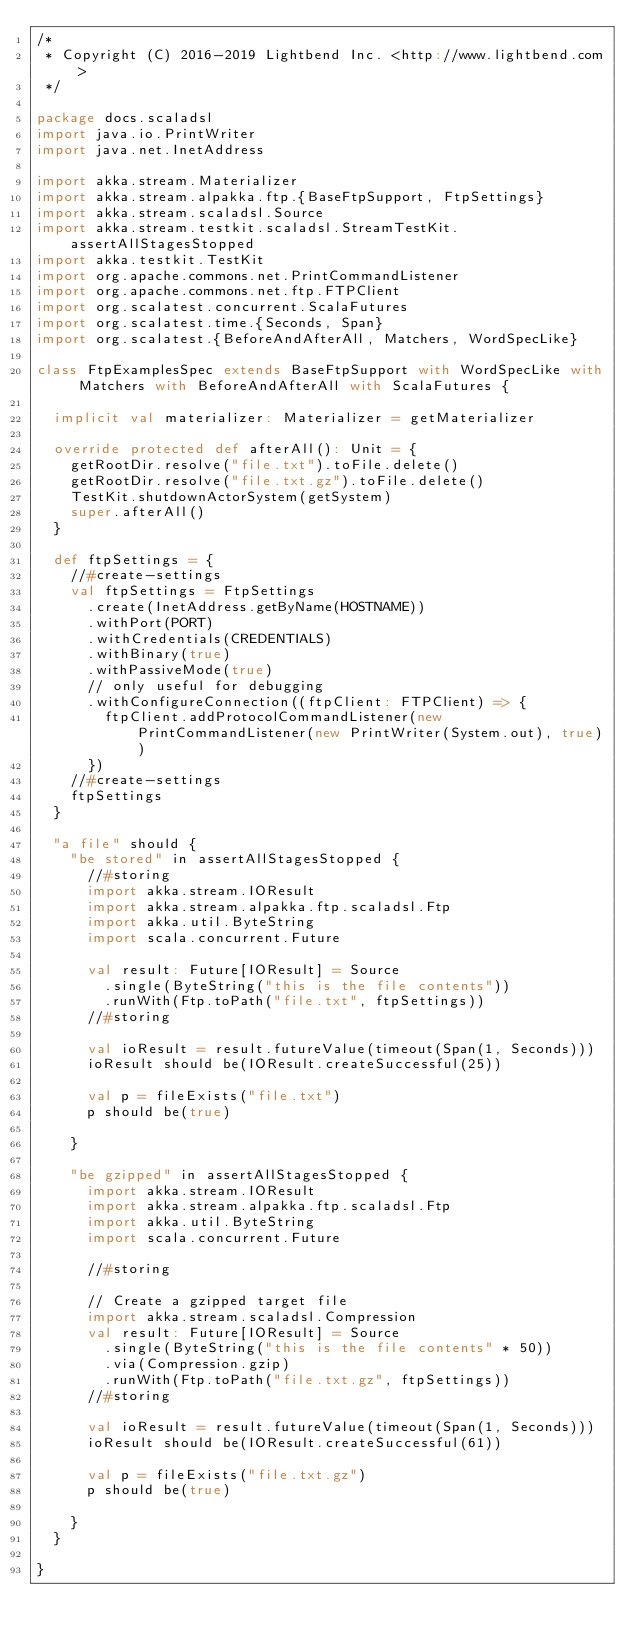Convert code to text. <code><loc_0><loc_0><loc_500><loc_500><_Scala_>/*
 * Copyright (C) 2016-2019 Lightbend Inc. <http://www.lightbend.com>
 */

package docs.scaladsl
import java.io.PrintWriter
import java.net.InetAddress

import akka.stream.Materializer
import akka.stream.alpakka.ftp.{BaseFtpSupport, FtpSettings}
import akka.stream.scaladsl.Source
import akka.stream.testkit.scaladsl.StreamTestKit.assertAllStagesStopped
import akka.testkit.TestKit
import org.apache.commons.net.PrintCommandListener
import org.apache.commons.net.ftp.FTPClient
import org.scalatest.concurrent.ScalaFutures
import org.scalatest.time.{Seconds, Span}
import org.scalatest.{BeforeAndAfterAll, Matchers, WordSpecLike}

class FtpExamplesSpec extends BaseFtpSupport with WordSpecLike with Matchers with BeforeAndAfterAll with ScalaFutures {

  implicit val materializer: Materializer = getMaterializer

  override protected def afterAll(): Unit = {
    getRootDir.resolve("file.txt").toFile.delete()
    getRootDir.resolve("file.txt.gz").toFile.delete()
    TestKit.shutdownActorSystem(getSystem)
    super.afterAll()
  }

  def ftpSettings = {
    //#create-settings
    val ftpSettings = FtpSettings
      .create(InetAddress.getByName(HOSTNAME))
      .withPort(PORT)
      .withCredentials(CREDENTIALS)
      .withBinary(true)
      .withPassiveMode(true)
      // only useful for debugging
      .withConfigureConnection((ftpClient: FTPClient) => {
        ftpClient.addProtocolCommandListener(new PrintCommandListener(new PrintWriter(System.out), true))
      })
    //#create-settings
    ftpSettings
  }

  "a file" should {
    "be stored" in assertAllStagesStopped {
      //#storing
      import akka.stream.IOResult
      import akka.stream.alpakka.ftp.scaladsl.Ftp
      import akka.util.ByteString
      import scala.concurrent.Future

      val result: Future[IOResult] = Source
        .single(ByteString("this is the file contents"))
        .runWith(Ftp.toPath("file.txt", ftpSettings))
      //#storing

      val ioResult = result.futureValue(timeout(Span(1, Seconds)))
      ioResult should be(IOResult.createSuccessful(25))

      val p = fileExists("file.txt")
      p should be(true)

    }

    "be gzipped" in assertAllStagesStopped {
      import akka.stream.IOResult
      import akka.stream.alpakka.ftp.scaladsl.Ftp
      import akka.util.ByteString
      import scala.concurrent.Future

      //#storing

      // Create a gzipped target file
      import akka.stream.scaladsl.Compression
      val result: Future[IOResult] = Source
        .single(ByteString("this is the file contents" * 50))
        .via(Compression.gzip)
        .runWith(Ftp.toPath("file.txt.gz", ftpSettings))
      //#storing

      val ioResult = result.futureValue(timeout(Span(1, Seconds)))
      ioResult should be(IOResult.createSuccessful(61))

      val p = fileExists("file.txt.gz")
      p should be(true)

    }
  }

}
</code> 